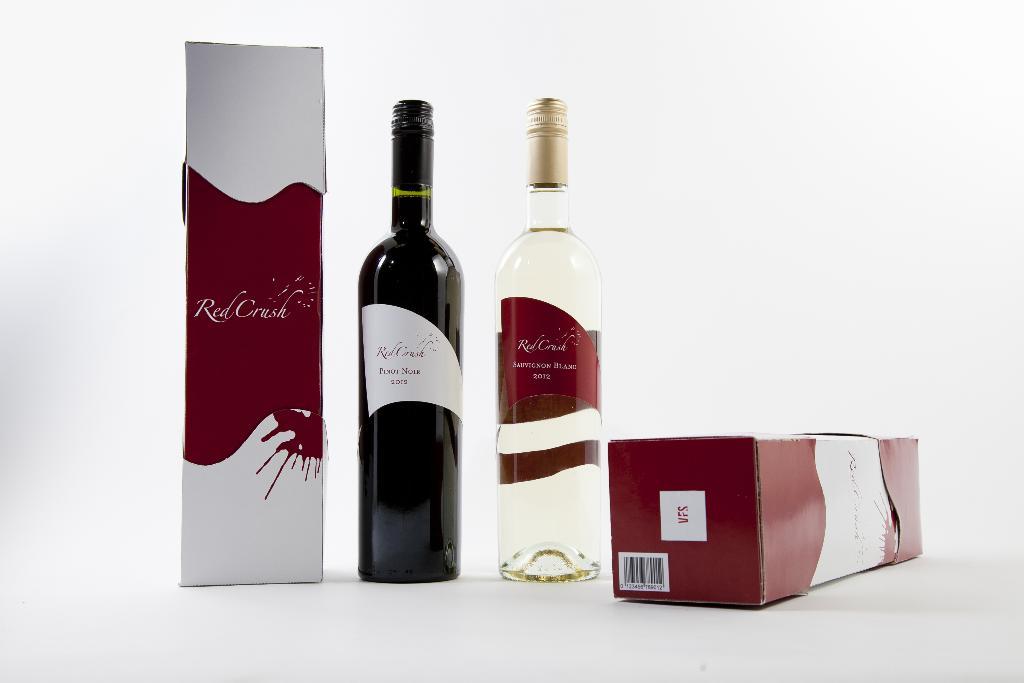What's the name of the wine with the red label?
Offer a very short reply. Red crush. What year is the wine?
Ensure brevity in your answer.  Unanswerable. 